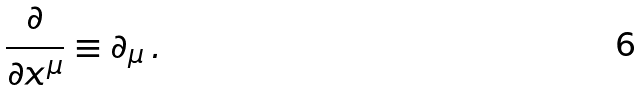Convert formula to latex. <formula><loc_0><loc_0><loc_500><loc_500>\frac { \partial } { \partial x ^ { \mu } } \equiv \partial _ { \mu } \, .</formula> 